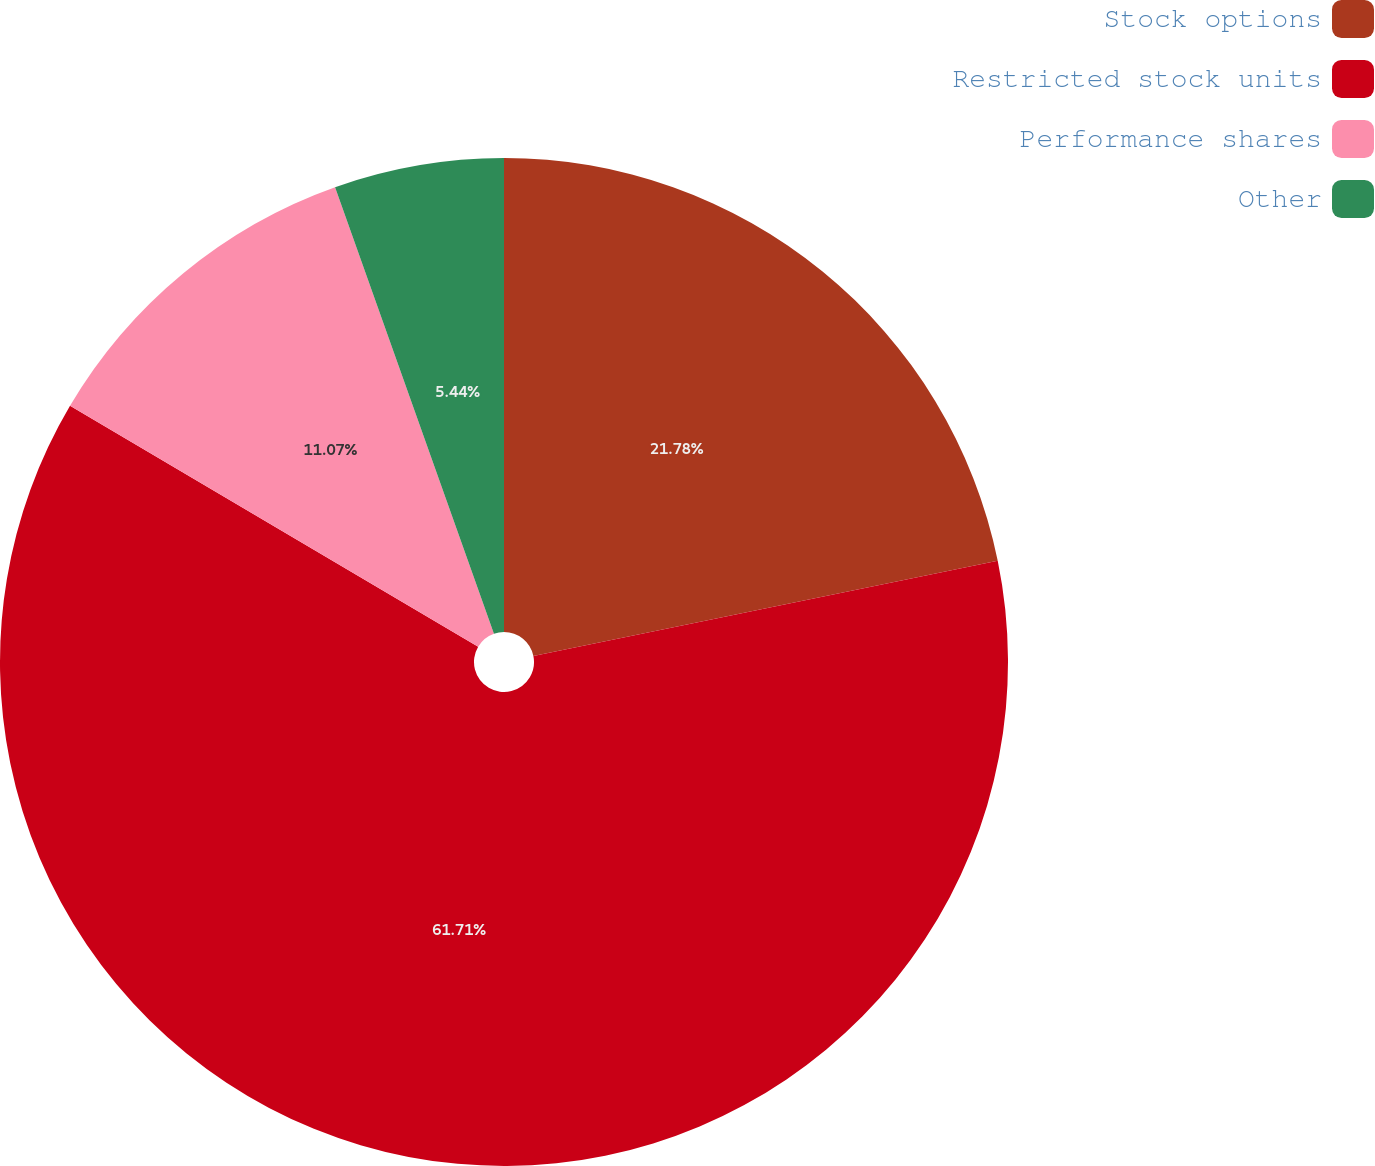Convert chart. <chart><loc_0><loc_0><loc_500><loc_500><pie_chart><fcel>Stock options<fcel>Restricted stock units<fcel>Performance shares<fcel>Other<nl><fcel>21.78%<fcel>61.71%<fcel>11.07%<fcel>5.44%<nl></chart> 